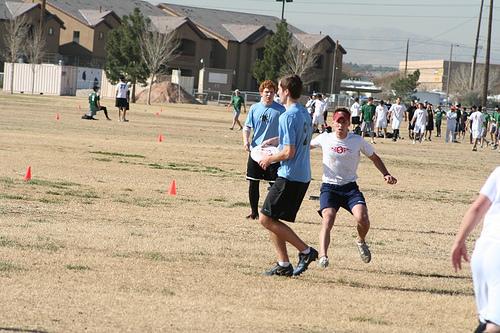How many boys are holding Frisbees?
Be succinct. 1. Is there anyone on the skateboard?
Short answer required. No. Which time of day was the pic taken?
Write a very short answer. Afternoon. What sport is being played?
Write a very short answer. Frisbee. How many orange cones are there in the picture?
Give a very brief answer. 7. What is the white object the man is holding?
Concise answer only. Frisbee. What job do the men in the picture do?
Answer briefly. Play frisbee. 